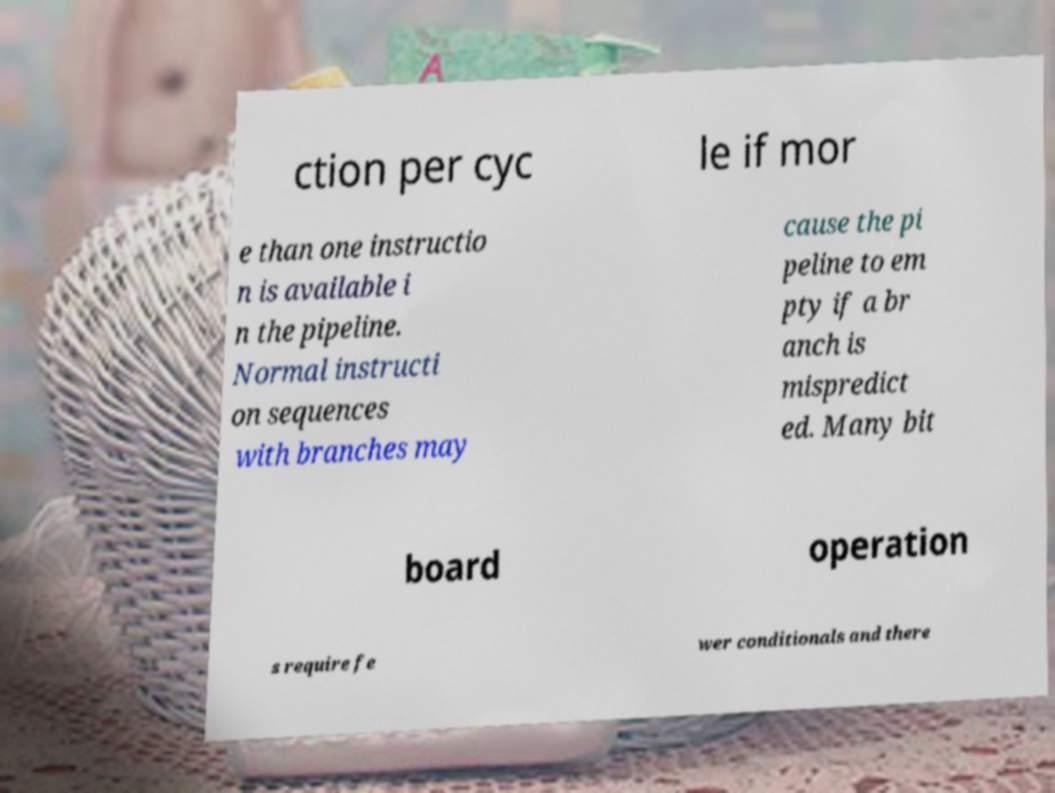Please identify and transcribe the text found in this image. ction per cyc le if mor e than one instructio n is available i n the pipeline. Normal instructi on sequences with branches may cause the pi peline to em pty if a br anch is mispredict ed. Many bit board operation s require fe wer conditionals and there 